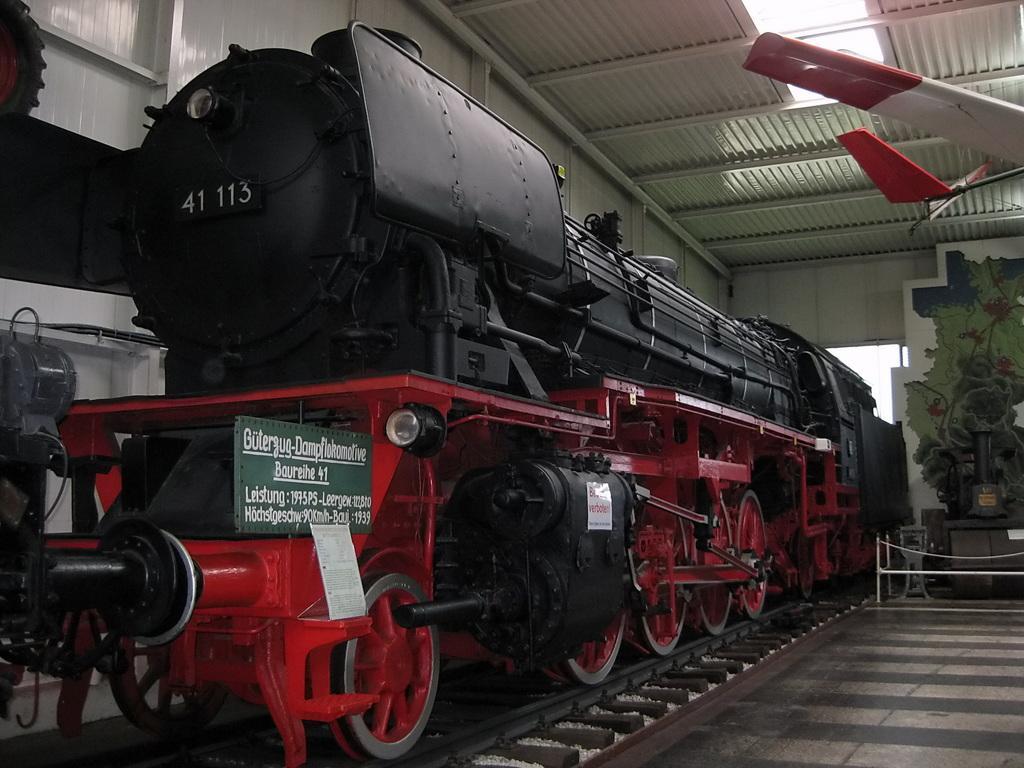Can you describe this image briefly? In this image I can see the train on the track. The train is in red and black color. And I can see the board to the train. To the right I can see the green color painting to the wall and I can also see the aircraft wings which are in red and white color. These are in the shed. 